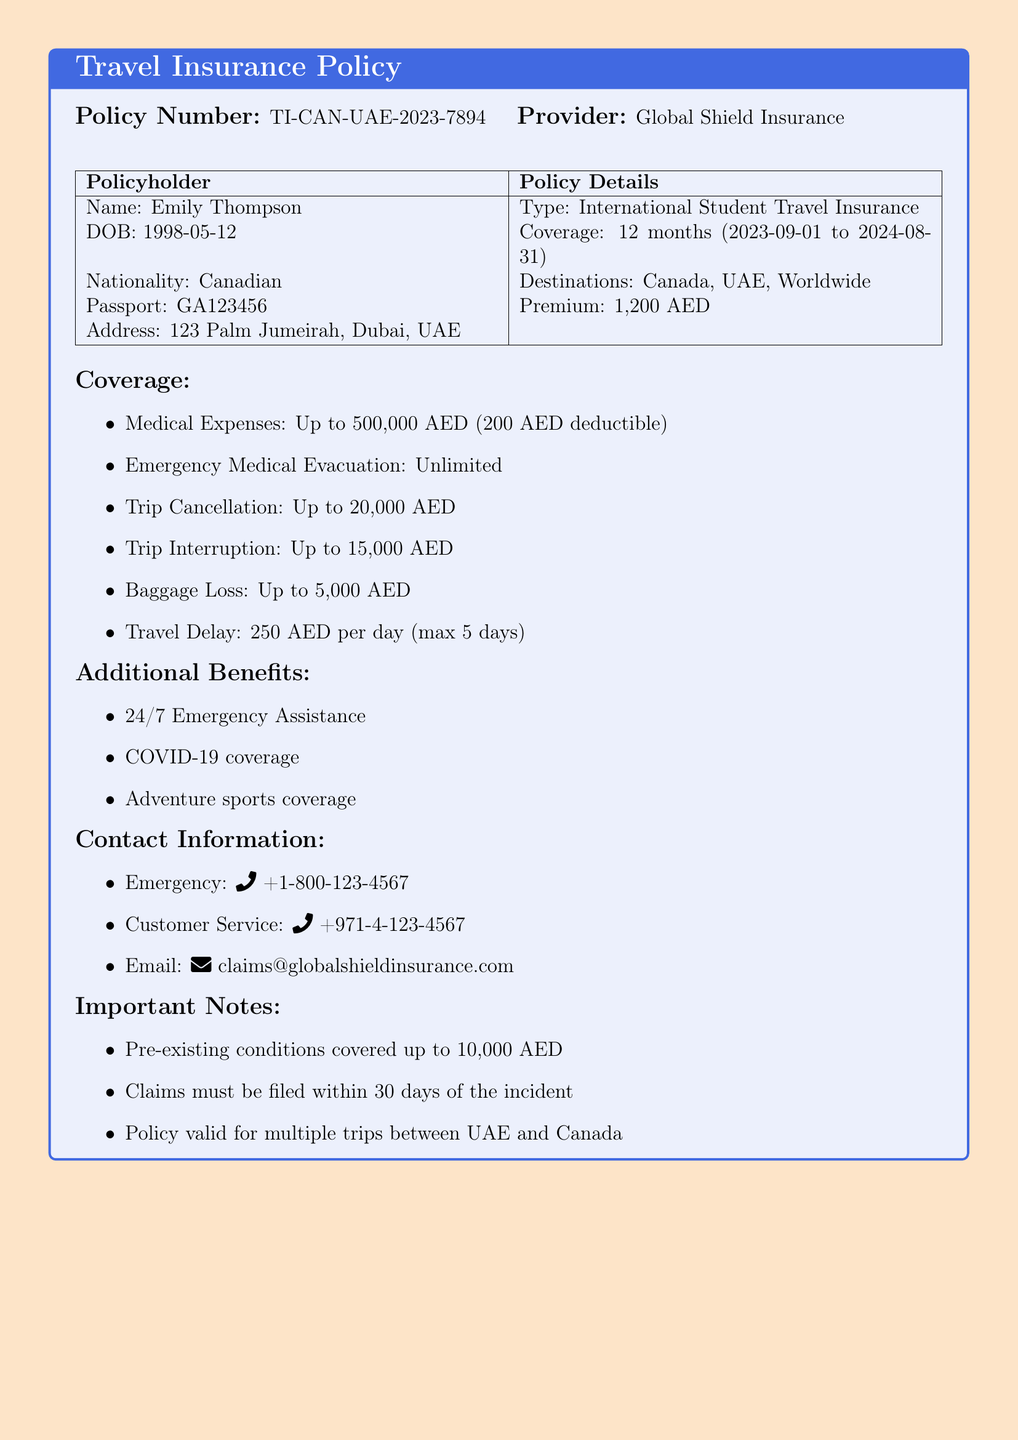What is the policy number? The policy number is explicitly stated in the document under the Policy Number section.
Answer: TI-CAN-UAE-2023-7894 What is the name of the provider? The provider's name is mentioned in the title of the insurance policy box.
Answer: Global Shield Insurance What is the coverage amount for medical expenses? The coverage amount for medical expenses is listed under the Coverage section.
Answer: Up to 500,000 AED What is the deductible for medical expenses? The deductible amount is stated clearly in the Coverage section.
Answer: 200 AED What is the premium payment for this policy? The premium amount is found in the Policy Details table of the document.
Answer: 1,200 AED How long is the coverage valid? The coverage period is given in the Coverage section of the document.
Answer: 12 months (2023-09-01 to 2024-08-31) What is covered under trip cancellation? The document specifies the coverage amount for trip cancellation in the Coverage list.
Answer: Up to 20,000 AED How much is the baggage loss coverage? The baggage loss coverage amount is mentioned in the Coverage section.
Answer: Up to 5,000 AED What is included in the additional benefits? The additional benefits are listed in a separate itemized list in the document.
Answer: 24/7 Emergency Assistance, COVID-19 coverage, Adventure sports coverage 